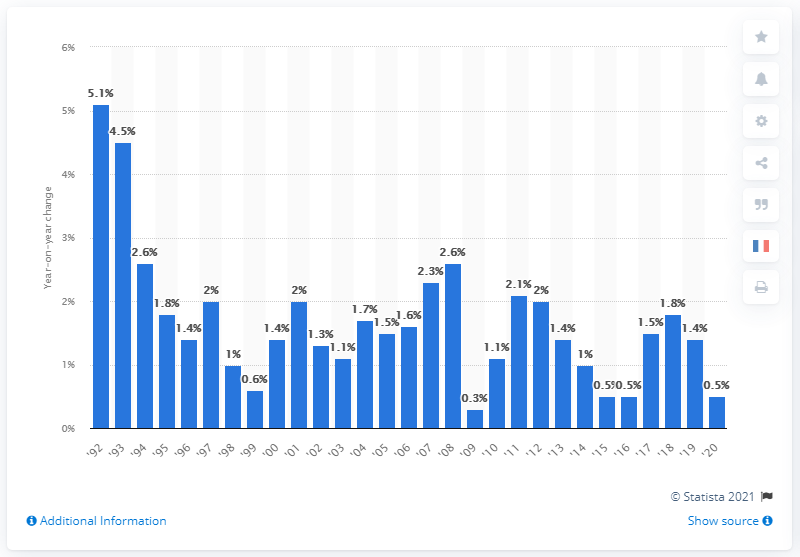Draw attention to some important aspects in this diagram. The inflation rate in Germany in 2020 was 0.5%. 